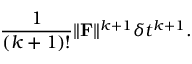Convert formula to latex. <formula><loc_0><loc_0><loc_500><loc_500>\frac { 1 } ( k + 1 ) ! } \| \mathbf F \| ^ { k + 1 } \delta t ^ { k + 1 } .</formula> 